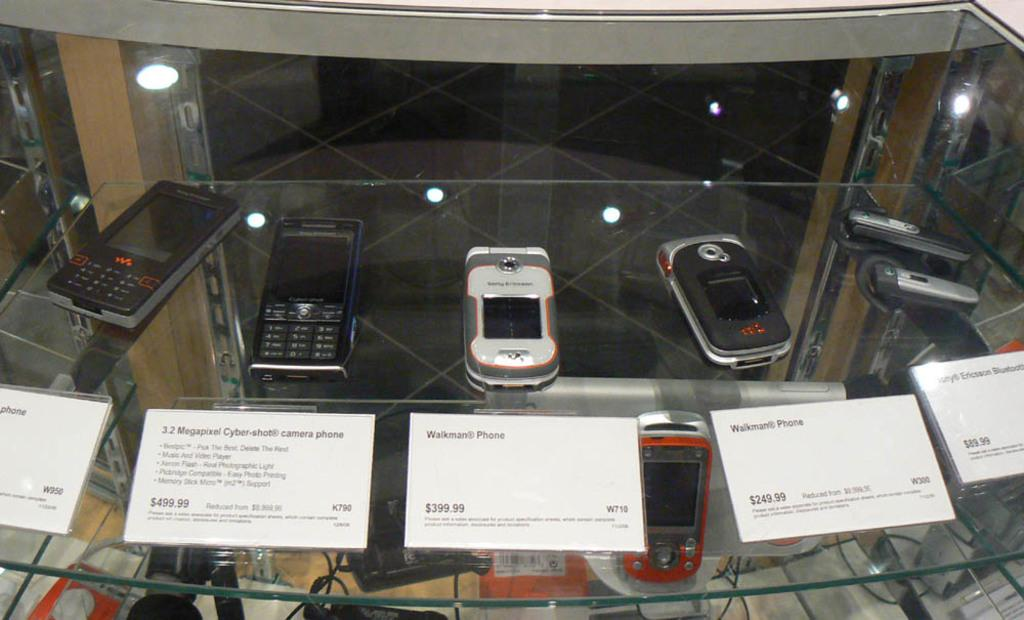<image>
Create a compact narrative representing the image presented. Phones on display with the Walkman Phone in the middle for $399.99. 